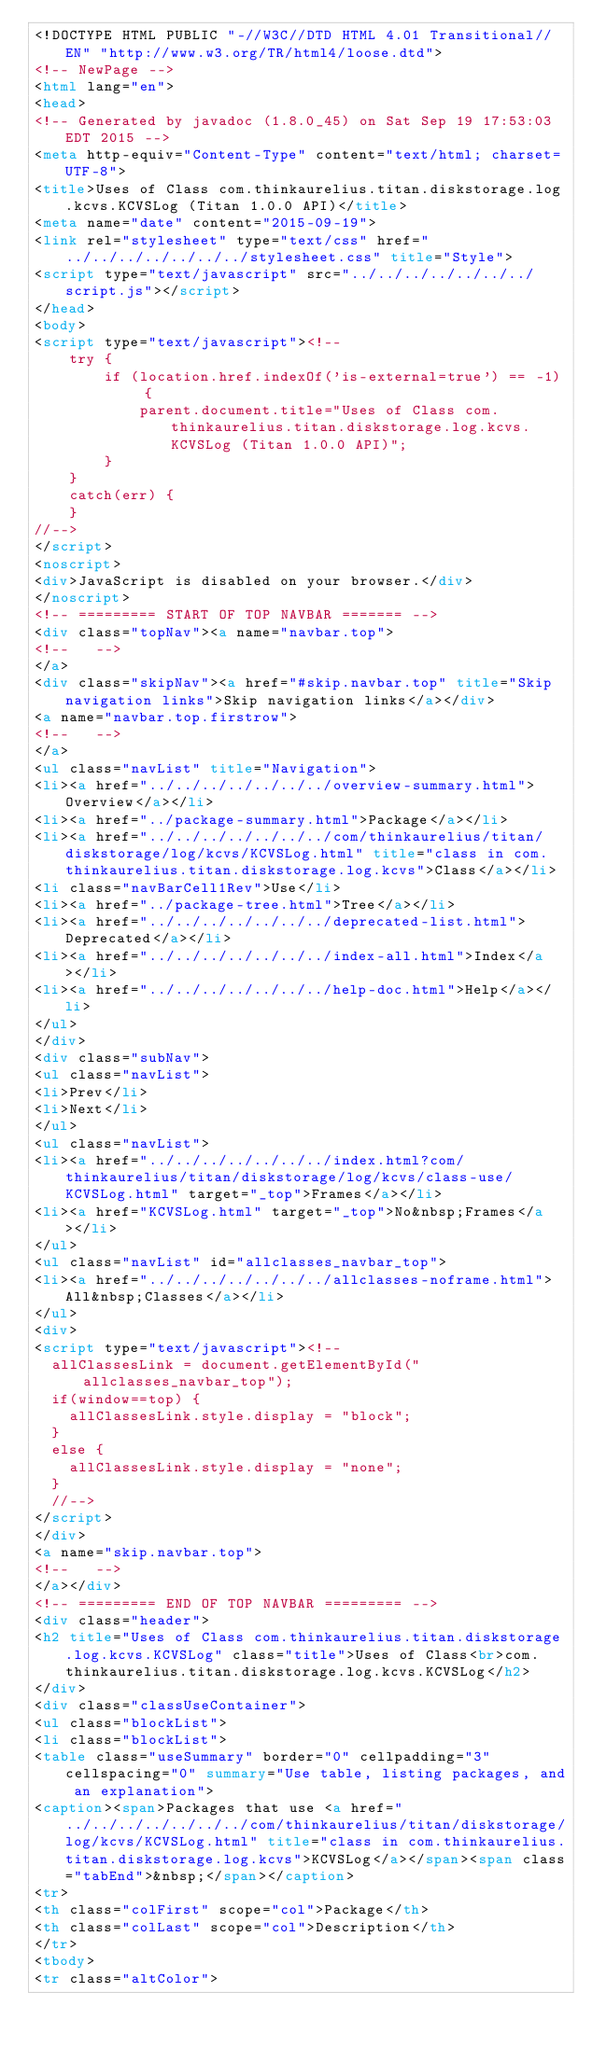Convert code to text. <code><loc_0><loc_0><loc_500><loc_500><_HTML_><!DOCTYPE HTML PUBLIC "-//W3C//DTD HTML 4.01 Transitional//EN" "http://www.w3.org/TR/html4/loose.dtd">
<!-- NewPage -->
<html lang="en">
<head>
<!-- Generated by javadoc (1.8.0_45) on Sat Sep 19 17:53:03 EDT 2015 -->
<meta http-equiv="Content-Type" content="text/html; charset=UTF-8">
<title>Uses of Class com.thinkaurelius.titan.diskstorage.log.kcvs.KCVSLog (Titan 1.0.0 API)</title>
<meta name="date" content="2015-09-19">
<link rel="stylesheet" type="text/css" href="../../../../../../../stylesheet.css" title="Style">
<script type="text/javascript" src="../../../../../../../script.js"></script>
</head>
<body>
<script type="text/javascript"><!--
    try {
        if (location.href.indexOf('is-external=true') == -1) {
            parent.document.title="Uses of Class com.thinkaurelius.titan.diskstorage.log.kcvs.KCVSLog (Titan 1.0.0 API)";
        }
    }
    catch(err) {
    }
//-->
</script>
<noscript>
<div>JavaScript is disabled on your browser.</div>
</noscript>
<!-- ========= START OF TOP NAVBAR ======= -->
<div class="topNav"><a name="navbar.top">
<!--   -->
</a>
<div class="skipNav"><a href="#skip.navbar.top" title="Skip navigation links">Skip navigation links</a></div>
<a name="navbar.top.firstrow">
<!--   -->
</a>
<ul class="navList" title="Navigation">
<li><a href="../../../../../../../overview-summary.html">Overview</a></li>
<li><a href="../package-summary.html">Package</a></li>
<li><a href="../../../../../../../com/thinkaurelius/titan/diskstorage/log/kcvs/KCVSLog.html" title="class in com.thinkaurelius.titan.diskstorage.log.kcvs">Class</a></li>
<li class="navBarCell1Rev">Use</li>
<li><a href="../package-tree.html">Tree</a></li>
<li><a href="../../../../../../../deprecated-list.html">Deprecated</a></li>
<li><a href="../../../../../../../index-all.html">Index</a></li>
<li><a href="../../../../../../../help-doc.html">Help</a></li>
</ul>
</div>
<div class="subNav">
<ul class="navList">
<li>Prev</li>
<li>Next</li>
</ul>
<ul class="navList">
<li><a href="../../../../../../../index.html?com/thinkaurelius/titan/diskstorage/log/kcvs/class-use/KCVSLog.html" target="_top">Frames</a></li>
<li><a href="KCVSLog.html" target="_top">No&nbsp;Frames</a></li>
</ul>
<ul class="navList" id="allclasses_navbar_top">
<li><a href="../../../../../../../allclasses-noframe.html">All&nbsp;Classes</a></li>
</ul>
<div>
<script type="text/javascript"><!--
  allClassesLink = document.getElementById("allclasses_navbar_top");
  if(window==top) {
    allClassesLink.style.display = "block";
  }
  else {
    allClassesLink.style.display = "none";
  }
  //-->
</script>
</div>
<a name="skip.navbar.top">
<!--   -->
</a></div>
<!-- ========= END OF TOP NAVBAR ========= -->
<div class="header">
<h2 title="Uses of Class com.thinkaurelius.titan.diskstorage.log.kcvs.KCVSLog" class="title">Uses of Class<br>com.thinkaurelius.titan.diskstorage.log.kcvs.KCVSLog</h2>
</div>
<div class="classUseContainer">
<ul class="blockList">
<li class="blockList">
<table class="useSummary" border="0" cellpadding="3" cellspacing="0" summary="Use table, listing packages, and an explanation">
<caption><span>Packages that use <a href="../../../../../../../com/thinkaurelius/titan/diskstorage/log/kcvs/KCVSLog.html" title="class in com.thinkaurelius.titan.diskstorage.log.kcvs">KCVSLog</a></span><span class="tabEnd">&nbsp;</span></caption>
<tr>
<th class="colFirst" scope="col">Package</th>
<th class="colLast" scope="col">Description</th>
</tr>
<tbody>
<tr class="altColor"></code> 